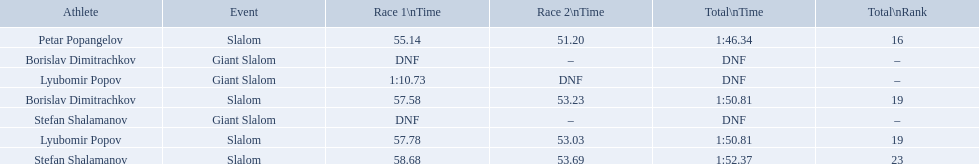What were the event names during bulgaria at the 1988 winter olympics? Stefan Shalamanov, Borislav Dimitrachkov, Lyubomir Popov. And which players participated at giant slalom? Giant Slalom, Giant Slalom, Giant Slalom, Slalom, Slalom, Slalom, Slalom. What were their race 1 times? DNF, DNF, 1:10.73. What was lyubomir popov's personal time? 1:10.73. 